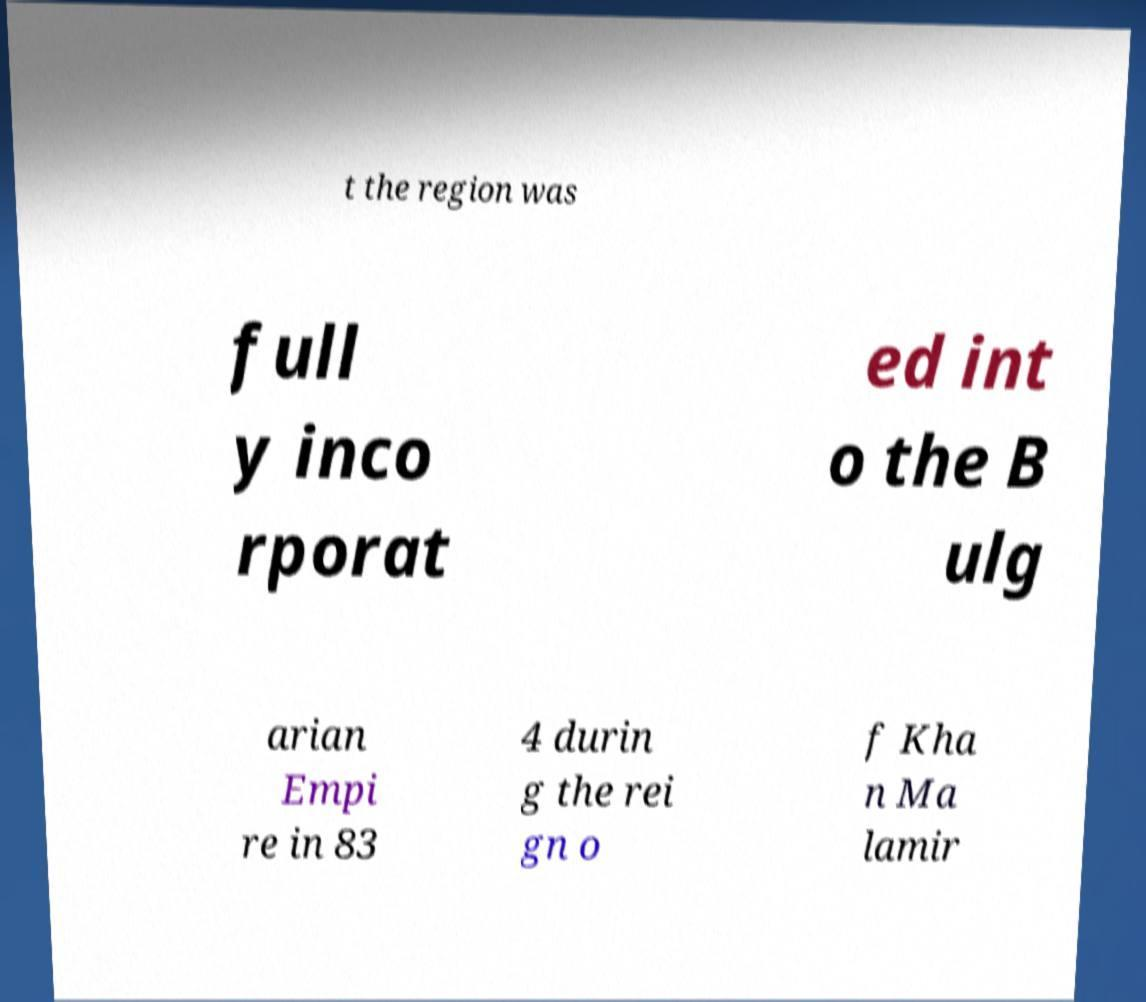Please read and relay the text visible in this image. What does it say? t the region was full y inco rporat ed int o the B ulg arian Empi re in 83 4 durin g the rei gn o f Kha n Ma lamir 